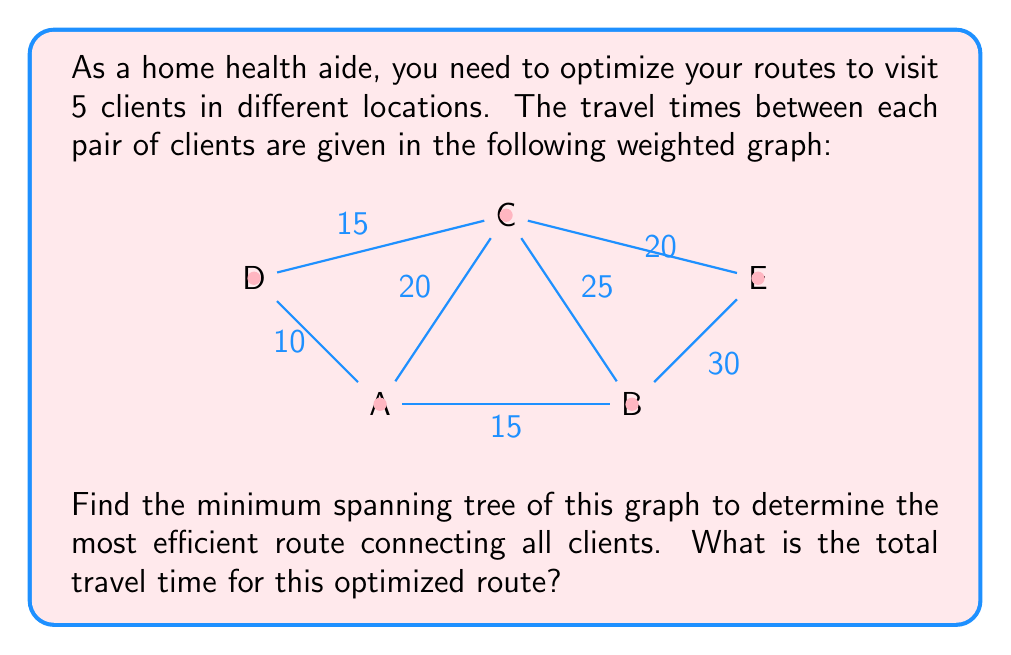Provide a solution to this math problem. To solve this problem, we'll use Kruskal's algorithm to find the minimum spanning tree of the given graph. This will give us the most efficient route connecting all clients with the minimum total travel time.

Steps:

1) List all edges in ascending order of weight (travel time):
   A-D: 10
   A-B: 15
   C-D: 15
   A-C: 20
   C-E: 20
   B-C: 25
   B-E: 30

2) Start with an empty set of edges and add edges one by one, skipping any that would create a cycle:

   - Add A-D (10)
   - Add A-B (15)
   - Add C-D (15)
   - Add A-C (20) (skip, would create cycle)
   - Add C-E (20)

3) We now have a minimum spanning tree with 4 edges connecting all 5 vertices:

   A-D: 10
   A-B: 15
   C-D: 15
   C-E: 20

4) Calculate the total travel time by summing the weights of these edges:

   Total time = 10 + 15 + 15 + 20 = 60 minutes

Therefore, the most efficient route connecting all clients has a total travel time of 60 minutes.
Answer: 60 minutes 